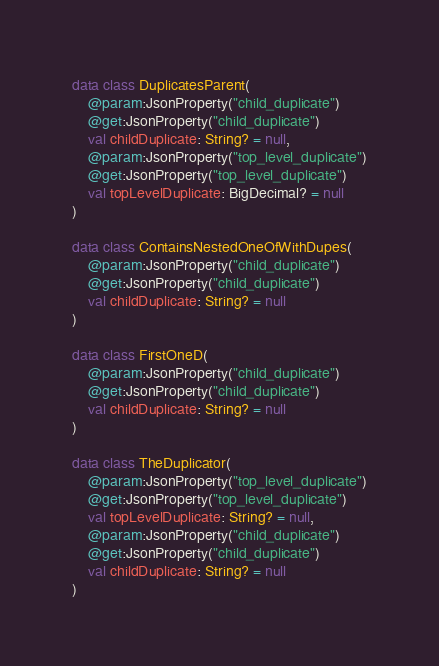Convert code to text. <code><loc_0><loc_0><loc_500><loc_500><_Kotlin_>
data class DuplicatesParent(
    @param:JsonProperty("child_duplicate")
    @get:JsonProperty("child_duplicate")
    val childDuplicate: String? = null,
    @param:JsonProperty("top_level_duplicate")
    @get:JsonProperty("top_level_duplicate")
    val topLevelDuplicate: BigDecimal? = null
)

data class ContainsNestedOneOfWithDupes(
    @param:JsonProperty("child_duplicate")
    @get:JsonProperty("child_duplicate")
    val childDuplicate: String? = null
)

data class FirstOneD(
    @param:JsonProperty("child_duplicate")
    @get:JsonProperty("child_duplicate")
    val childDuplicate: String? = null
)

data class TheDuplicator(
    @param:JsonProperty("top_level_duplicate")
    @get:JsonProperty("top_level_duplicate")
    val topLevelDuplicate: String? = null,
    @param:JsonProperty("child_duplicate")
    @get:JsonProperty("child_duplicate")
    val childDuplicate: String? = null
)
</code> 